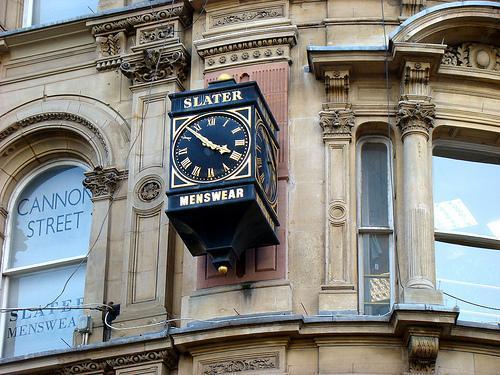How many clocks are seen?
Give a very brief answer. 1. 